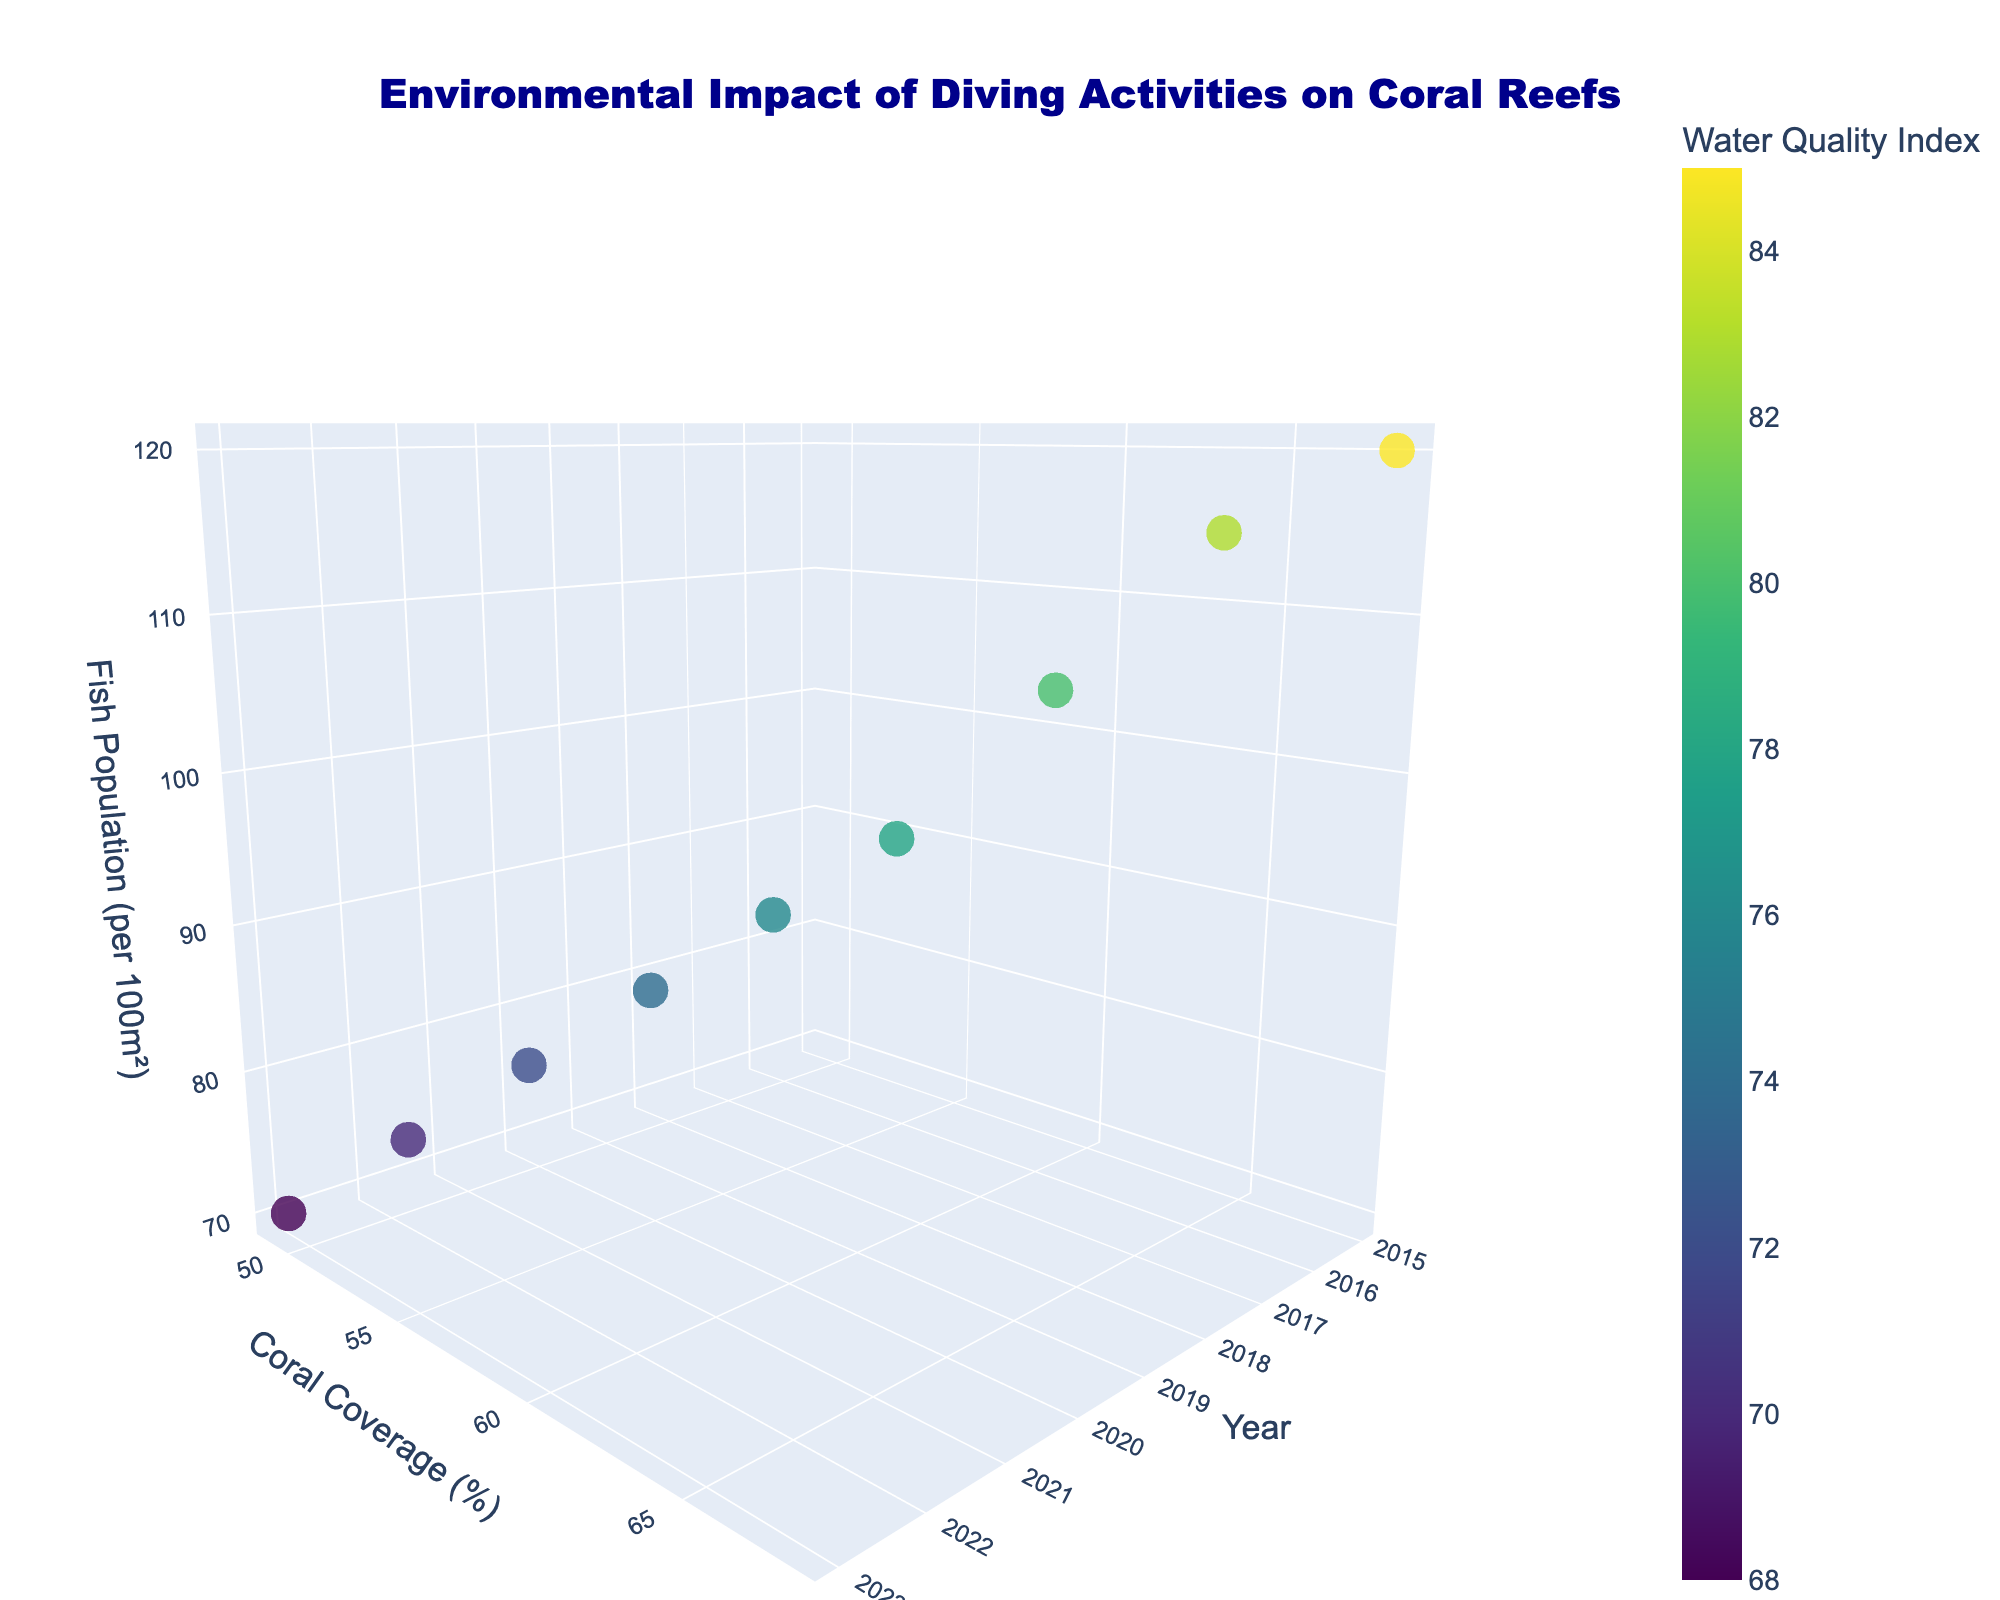What is the title of the plot? The title is typically displayed at the top of the plot and provides an overview of what the chart represents. In this case, it indicates what the plot is about.
Answer: Environmental Impact of Diving Activities on Coral Reefs What are the axes labeled with? By looking at the three axes, each axis title indicates what aspect of the data they represent. The x-axis is labeled with the Year, the y-axis with Coral Coverage (%), and the z-axis with Fish Population (per 100m²).
Answer: Year, Coral Coverage (%), Fish Population (per 100m²) How many data points are shown in the plot? The total number of data points can be counted visually, each point representing a single year from the dataset. There are 9 data points representing the years from 2015 to 2023.
Answer: 9 Which year had the highest coral coverage percentage? The highest position on the y-axis represents the highest coral coverage percentage. The data point at the highest y position corresponds to the year 2015.
Answer: 2015 What is the trend of fish population over the years presented in the plot? By observing the z-axis locations of the data points, the fish population is decreasing from 2015 to 2023.
Answer: Decreasing Which year has the lowest water quality index? By observing the marker colors, we see that darker colors represent lower water quality index values. The year with the darkest marker will indicate the lowest water quality index, which is 2023.
Answer: 2023 How does water quality index relate to coral coverage and fish population? Observe the correlation of the marker colors with their positions on the y-axis (coral coverage) and z-axis (fish population). Markers with darker colors, indicating lower water quality, tend to be lower in y and z axes, indicating lower coral coverage and fish population.
Answer: Lower water quality is associated with lower coral coverage and fish population What is the difference in coral coverage between the years 2015 and 2020? The coral coverage percentage for 2015 is 68% and for 2020 is 55%. Subtracting these values gives the difference. 68 - 55 = 13
Answer: 13% How does the fish population change from 2015 to 2023? The fish population in 2015 is 120, and in 2023 it is 70. The change is calculated by subtracting the population in 2023 from that in 2015: 120 - 70 = 50
Answer: Decreased by 50 Is there any year where both coral coverage and fish population are at their maximum values simultaneously? Look for the highest y (coral coverage) and z (fish population) values and check if they occur for the same year. The maximum coral coverage (68%) and fish population (120) both occur in 2015.
Answer: Yes, in 2015 